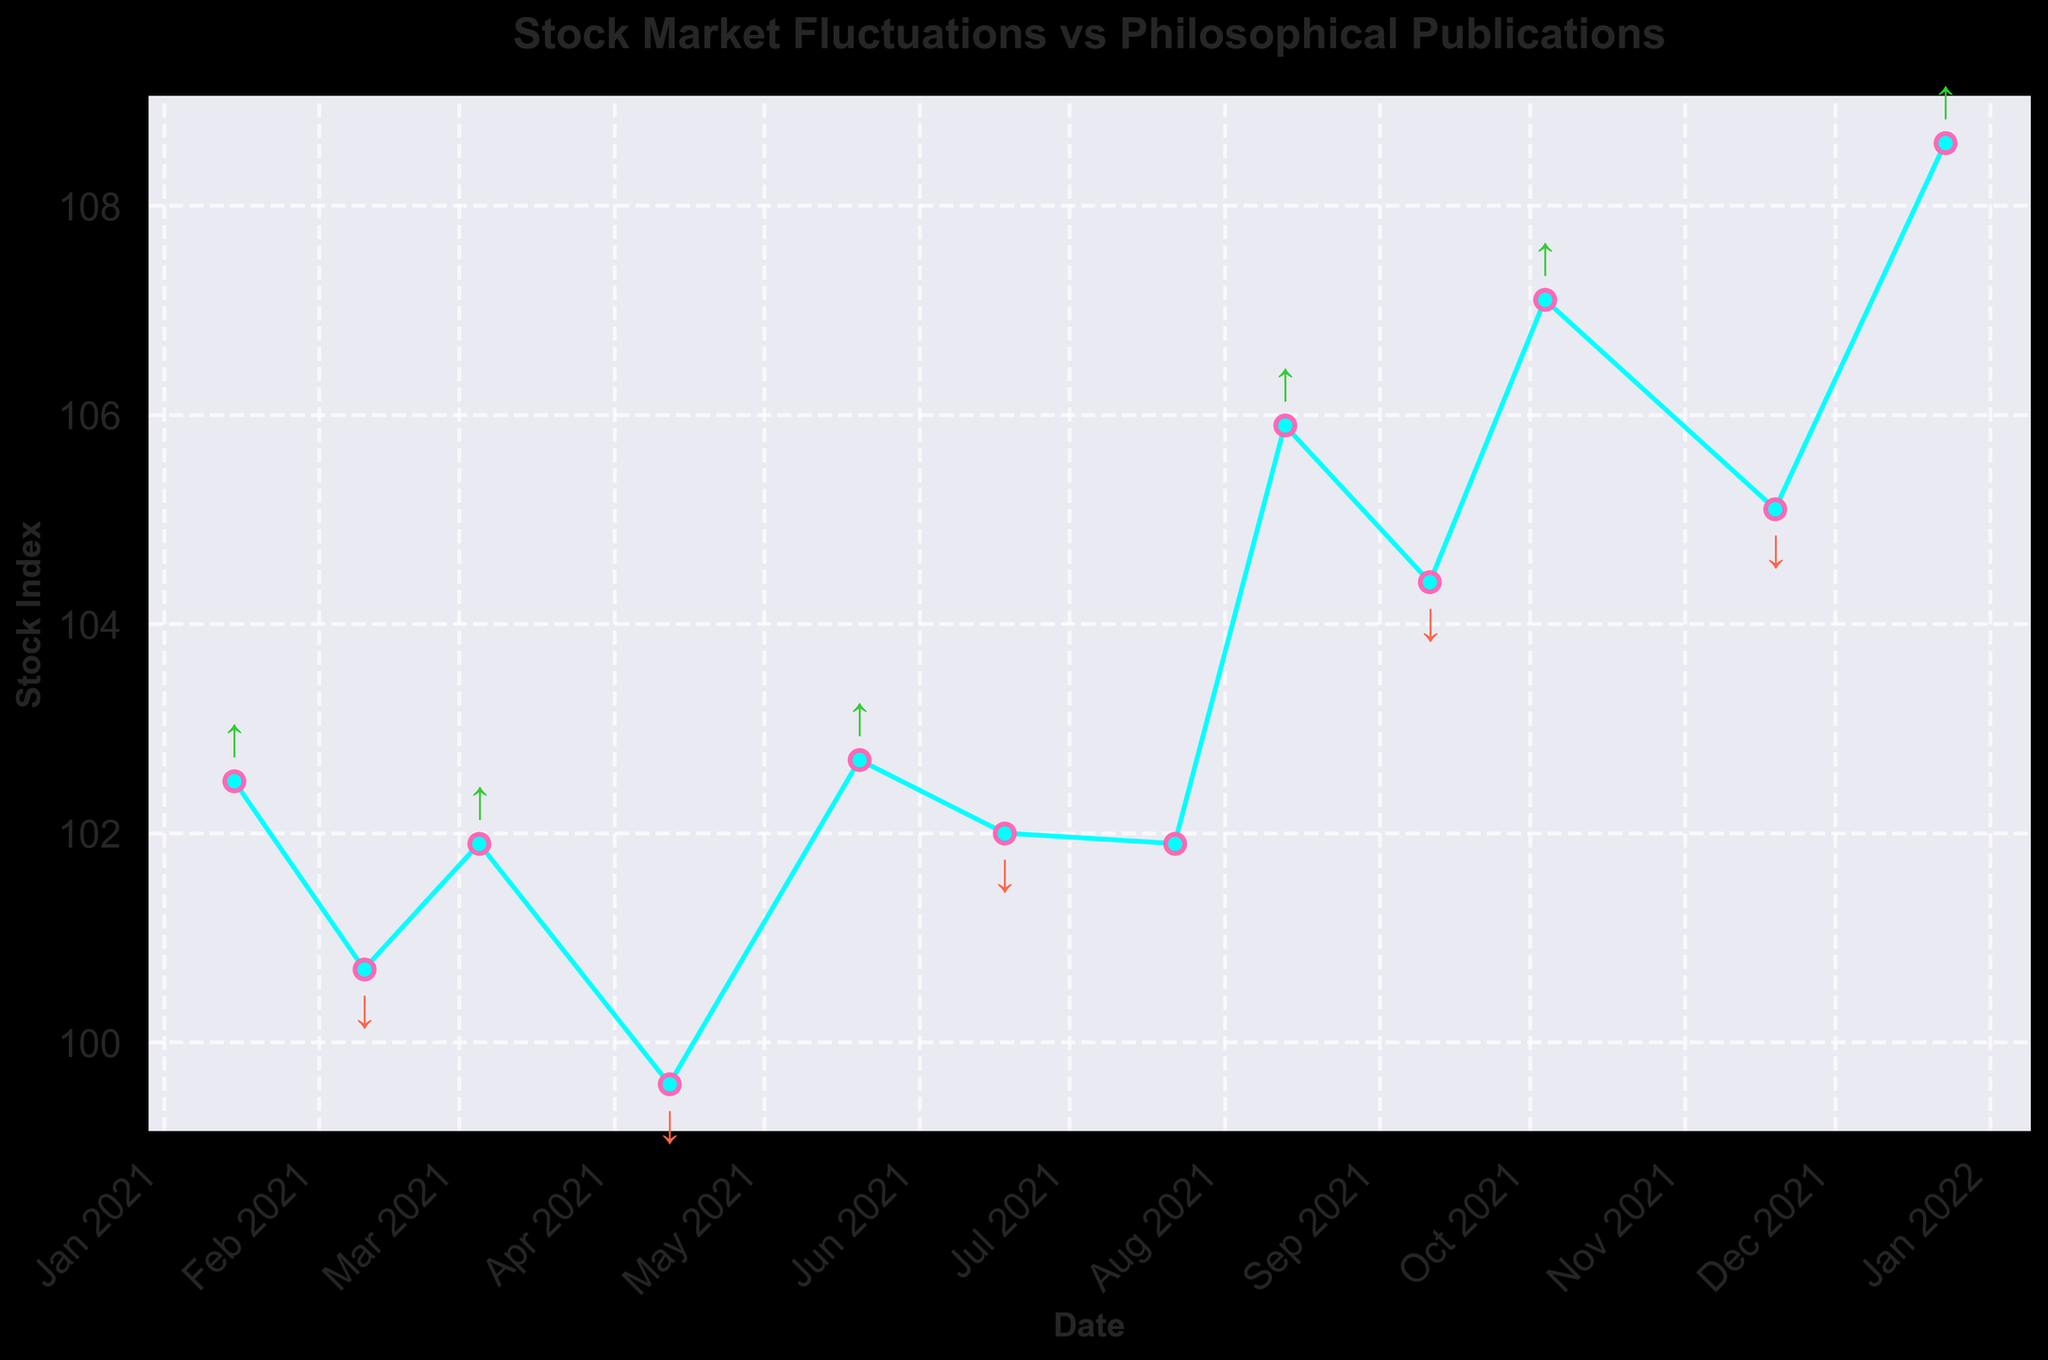What is the title of the plot? The title is located at the top of the plot. It provides an overview of what the plot represents. By reading the title, one can identify the context of the data visualized.
Answer: Stock Market Fluctuations vs Philosophical Publications How many data points are plotted in the graph? Counting the markers representing each data point along the plotted line allows you to determine the number of data points.
Answer: 12 Which philosophical stance is indicated by an upward arrow on the plot? Observing the annotations on the plot will reveal that the upward arrows are associated with points that have a particular philosophical stance. These arrows indicate the dates and corresponding stock index changes.
Answer: Idealism What is the color used for the line connecting the data points? The color of the line can be identified by looking at the line itself. The visualization uses specific colors for distinction.
Answer: Cyan On which date did the stock index change reach its lowest point on the plot? By observing the plotted line and the corresponding dates, one can locate the point where the stock index is lowest. This involves finding the minimum y-value on the plot and identifying the associated date.
Answer: April 12, 2021 What is the overall trend of the stock index throughout the year? By following the plotted line from the start to the end, the general direction or pattern of the stock index changes can be determined.
Answer: Upward How many times did philosophical publications with a stance of "Materialism" correspond to a decrease in the stock index? By counting the downward arrows (which indicate "Materialism") on the plot, one can determine how many times publications with this stance correlated with a decrease.
Answer: 6 Calculate the cumulative stock index change for publications with an "Idealism" stance. First, identify the stock index changes for each "Idealism" data point, then sum them up. The changes are 2.5, 1.2, 3.1, 4.0, 2.7, and 3.5. So, 2.5 + 1.2 + 3.1 + 4.0 + 2.7 + 3.5 = 17.
Answer: 17 Did any "Mixed" philosophical stances correlate with an increase in the stock index? Observing the annotations for the "Mixed" stance (indicated by markers without arrows) while checking the corresponding stock index change will show whether there was an increase or decrease.
Answer: No How does the stock index change following the publication "The Third Way: Reconciling Idealism and Materialism in Contemporary Philosophy"? Finding the date of this publication and looking at the corresponding stock index change on the plot will reveal the effect of this publication on the stock index.
Answer: -0.1 